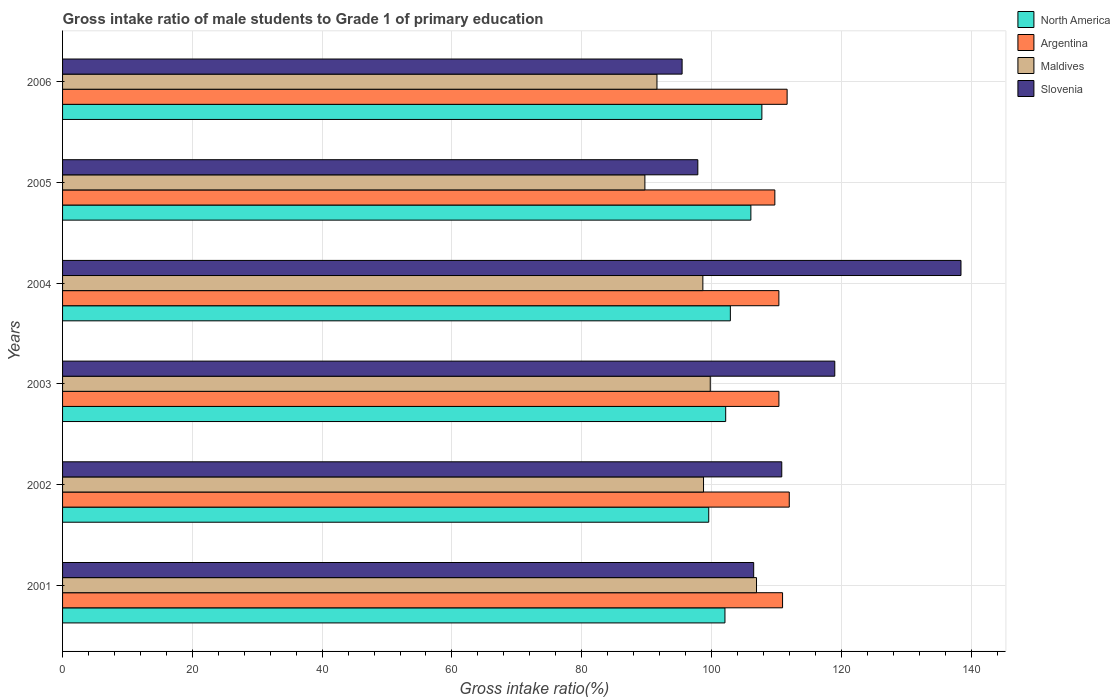How many different coloured bars are there?
Your response must be concise. 4. Are the number of bars per tick equal to the number of legend labels?
Provide a short and direct response. Yes. In how many cases, is the number of bars for a given year not equal to the number of legend labels?
Make the answer very short. 0. What is the gross intake ratio in Maldives in 2001?
Offer a very short reply. 106.93. Across all years, what is the maximum gross intake ratio in Maldives?
Offer a terse response. 106.93. Across all years, what is the minimum gross intake ratio in Argentina?
Your response must be concise. 109.76. In which year was the gross intake ratio in North America minimum?
Your response must be concise. 2002. What is the total gross intake ratio in Argentina in the graph?
Your answer should be very brief. 665.11. What is the difference between the gross intake ratio in North America in 2005 and that in 2006?
Your answer should be very brief. -1.7. What is the difference between the gross intake ratio in Argentina in 2004 and the gross intake ratio in North America in 2005?
Your answer should be very brief. 4.31. What is the average gross intake ratio in Slovenia per year?
Ensure brevity in your answer.  111.35. In the year 2004, what is the difference between the gross intake ratio in Slovenia and gross intake ratio in Argentina?
Your answer should be compact. 28.06. What is the ratio of the gross intake ratio in North America in 2002 to that in 2005?
Make the answer very short. 0.94. What is the difference between the highest and the second highest gross intake ratio in North America?
Keep it short and to the point. 1.7. What is the difference between the highest and the lowest gross intake ratio in Maldives?
Your response must be concise. 17.2. Is it the case that in every year, the sum of the gross intake ratio in Maldives and gross intake ratio in Argentina is greater than the sum of gross intake ratio in North America and gross intake ratio in Slovenia?
Ensure brevity in your answer.  No. What does the 4th bar from the top in 2004 represents?
Keep it short and to the point. North America. What does the 4th bar from the bottom in 2002 represents?
Your response must be concise. Slovenia. Is it the case that in every year, the sum of the gross intake ratio in Argentina and gross intake ratio in Maldives is greater than the gross intake ratio in North America?
Keep it short and to the point. Yes. How many bars are there?
Ensure brevity in your answer.  24. Are all the bars in the graph horizontal?
Provide a short and direct response. Yes. What is the difference between two consecutive major ticks on the X-axis?
Keep it short and to the point. 20. Are the values on the major ticks of X-axis written in scientific E-notation?
Make the answer very short. No. Where does the legend appear in the graph?
Your answer should be compact. Top right. How are the legend labels stacked?
Provide a short and direct response. Vertical. What is the title of the graph?
Offer a very short reply. Gross intake ratio of male students to Grade 1 of primary education. What is the label or title of the X-axis?
Ensure brevity in your answer.  Gross intake ratio(%). What is the label or title of the Y-axis?
Make the answer very short. Years. What is the Gross intake ratio(%) in North America in 2001?
Provide a succinct answer. 102.07. What is the Gross intake ratio(%) in Argentina in 2001?
Provide a succinct answer. 110.95. What is the Gross intake ratio(%) in Maldives in 2001?
Your answer should be very brief. 106.93. What is the Gross intake ratio(%) of Slovenia in 2001?
Make the answer very short. 106.5. What is the Gross intake ratio(%) in North America in 2002?
Ensure brevity in your answer.  99.57. What is the Gross intake ratio(%) in Argentina in 2002?
Give a very brief answer. 111.98. What is the Gross intake ratio(%) of Maldives in 2002?
Ensure brevity in your answer.  98.77. What is the Gross intake ratio(%) in Slovenia in 2002?
Provide a succinct answer. 110.83. What is the Gross intake ratio(%) in North America in 2003?
Your response must be concise. 102.18. What is the Gross intake ratio(%) of Argentina in 2003?
Give a very brief answer. 110.39. What is the Gross intake ratio(%) in Maldives in 2003?
Your response must be concise. 99.81. What is the Gross intake ratio(%) in Slovenia in 2003?
Your answer should be compact. 118.99. What is the Gross intake ratio(%) of North America in 2004?
Keep it short and to the point. 102.9. What is the Gross intake ratio(%) of Argentina in 2004?
Provide a succinct answer. 110.38. What is the Gross intake ratio(%) in Maldives in 2004?
Your answer should be compact. 98.67. What is the Gross intake ratio(%) of Slovenia in 2004?
Your answer should be very brief. 138.44. What is the Gross intake ratio(%) of North America in 2005?
Provide a succinct answer. 106.07. What is the Gross intake ratio(%) in Argentina in 2005?
Offer a very short reply. 109.76. What is the Gross intake ratio(%) in Maldives in 2005?
Offer a very short reply. 89.74. What is the Gross intake ratio(%) in Slovenia in 2005?
Provide a short and direct response. 97.89. What is the Gross intake ratio(%) of North America in 2006?
Provide a succinct answer. 107.76. What is the Gross intake ratio(%) in Argentina in 2006?
Make the answer very short. 111.65. What is the Gross intake ratio(%) in Maldives in 2006?
Provide a short and direct response. 91.59. What is the Gross intake ratio(%) in Slovenia in 2006?
Give a very brief answer. 95.47. Across all years, what is the maximum Gross intake ratio(%) of North America?
Your response must be concise. 107.76. Across all years, what is the maximum Gross intake ratio(%) in Argentina?
Offer a very short reply. 111.98. Across all years, what is the maximum Gross intake ratio(%) of Maldives?
Your answer should be very brief. 106.93. Across all years, what is the maximum Gross intake ratio(%) in Slovenia?
Keep it short and to the point. 138.44. Across all years, what is the minimum Gross intake ratio(%) of North America?
Provide a short and direct response. 99.57. Across all years, what is the minimum Gross intake ratio(%) in Argentina?
Ensure brevity in your answer.  109.76. Across all years, what is the minimum Gross intake ratio(%) of Maldives?
Your answer should be very brief. 89.74. Across all years, what is the minimum Gross intake ratio(%) in Slovenia?
Offer a terse response. 95.47. What is the total Gross intake ratio(%) in North America in the graph?
Your answer should be compact. 620.56. What is the total Gross intake ratio(%) of Argentina in the graph?
Your answer should be very brief. 665.11. What is the total Gross intake ratio(%) in Maldives in the graph?
Give a very brief answer. 585.51. What is the total Gross intake ratio(%) of Slovenia in the graph?
Offer a very short reply. 668.12. What is the difference between the Gross intake ratio(%) in North America in 2001 and that in 2002?
Provide a short and direct response. 2.5. What is the difference between the Gross intake ratio(%) of Argentina in 2001 and that in 2002?
Keep it short and to the point. -1.03. What is the difference between the Gross intake ratio(%) in Maldives in 2001 and that in 2002?
Keep it short and to the point. 8.16. What is the difference between the Gross intake ratio(%) of Slovenia in 2001 and that in 2002?
Provide a succinct answer. -4.33. What is the difference between the Gross intake ratio(%) of North America in 2001 and that in 2003?
Your answer should be very brief. -0.11. What is the difference between the Gross intake ratio(%) of Argentina in 2001 and that in 2003?
Your answer should be very brief. 0.56. What is the difference between the Gross intake ratio(%) of Maldives in 2001 and that in 2003?
Ensure brevity in your answer.  7.13. What is the difference between the Gross intake ratio(%) in Slovenia in 2001 and that in 2003?
Your answer should be compact. -12.49. What is the difference between the Gross intake ratio(%) in North America in 2001 and that in 2004?
Make the answer very short. -0.83. What is the difference between the Gross intake ratio(%) of Argentina in 2001 and that in 2004?
Your answer should be very brief. 0.57. What is the difference between the Gross intake ratio(%) of Maldives in 2001 and that in 2004?
Your response must be concise. 8.27. What is the difference between the Gross intake ratio(%) of Slovenia in 2001 and that in 2004?
Provide a succinct answer. -31.94. What is the difference between the Gross intake ratio(%) of North America in 2001 and that in 2005?
Give a very brief answer. -3.99. What is the difference between the Gross intake ratio(%) of Argentina in 2001 and that in 2005?
Offer a very short reply. 1.19. What is the difference between the Gross intake ratio(%) in Maldives in 2001 and that in 2005?
Provide a succinct answer. 17.2. What is the difference between the Gross intake ratio(%) of Slovenia in 2001 and that in 2005?
Provide a succinct answer. 8.61. What is the difference between the Gross intake ratio(%) in North America in 2001 and that in 2006?
Ensure brevity in your answer.  -5.69. What is the difference between the Gross intake ratio(%) of Argentina in 2001 and that in 2006?
Keep it short and to the point. -0.7. What is the difference between the Gross intake ratio(%) in Maldives in 2001 and that in 2006?
Offer a very short reply. 15.34. What is the difference between the Gross intake ratio(%) in Slovenia in 2001 and that in 2006?
Provide a succinct answer. 11.03. What is the difference between the Gross intake ratio(%) in North America in 2002 and that in 2003?
Give a very brief answer. -2.61. What is the difference between the Gross intake ratio(%) in Argentina in 2002 and that in 2003?
Offer a terse response. 1.6. What is the difference between the Gross intake ratio(%) in Maldives in 2002 and that in 2003?
Keep it short and to the point. -1.03. What is the difference between the Gross intake ratio(%) of Slovenia in 2002 and that in 2003?
Your answer should be very brief. -8.17. What is the difference between the Gross intake ratio(%) of North America in 2002 and that in 2004?
Make the answer very short. -3.33. What is the difference between the Gross intake ratio(%) in Argentina in 2002 and that in 2004?
Offer a very short reply. 1.6. What is the difference between the Gross intake ratio(%) of Maldives in 2002 and that in 2004?
Provide a short and direct response. 0.1. What is the difference between the Gross intake ratio(%) in Slovenia in 2002 and that in 2004?
Give a very brief answer. -27.62. What is the difference between the Gross intake ratio(%) in North America in 2002 and that in 2005?
Your response must be concise. -6.49. What is the difference between the Gross intake ratio(%) in Argentina in 2002 and that in 2005?
Make the answer very short. 2.22. What is the difference between the Gross intake ratio(%) of Maldives in 2002 and that in 2005?
Your answer should be compact. 9.04. What is the difference between the Gross intake ratio(%) in Slovenia in 2002 and that in 2005?
Provide a succinct answer. 12.93. What is the difference between the Gross intake ratio(%) of North America in 2002 and that in 2006?
Offer a very short reply. -8.19. What is the difference between the Gross intake ratio(%) in Argentina in 2002 and that in 2006?
Give a very brief answer. 0.33. What is the difference between the Gross intake ratio(%) of Maldives in 2002 and that in 2006?
Your response must be concise. 7.18. What is the difference between the Gross intake ratio(%) in Slovenia in 2002 and that in 2006?
Offer a terse response. 15.36. What is the difference between the Gross intake ratio(%) of North America in 2003 and that in 2004?
Your answer should be compact. -0.72. What is the difference between the Gross intake ratio(%) in Argentina in 2003 and that in 2004?
Offer a terse response. 0.01. What is the difference between the Gross intake ratio(%) of Maldives in 2003 and that in 2004?
Your answer should be very brief. 1.14. What is the difference between the Gross intake ratio(%) of Slovenia in 2003 and that in 2004?
Give a very brief answer. -19.45. What is the difference between the Gross intake ratio(%) of North America in 2003 and that in 2005?
Offer a terse response. -3.88. What is the difference between the Gross intake ratio(%) of Argentina in 2003 and that in 2005?
Provide a succinct answer. 0.63. What is the difference between the Gross intake ratio(%) of Maldives in 2003 and that in 2005?
Offer a very short reply. 10.07. What is the difference between the Gross intake ratio(%) in Slovenia in 2003 and that in 2005?
Your answer should be very brief. 21.1. What is the difference between the Gross intake ratio(%) of North America in 2003 and that in 2006?
Ensure brevity in your answer.  -5.58. What is the difference between the Gross intake ratio(%) in Argentina in 2003 and that in 2006?
Offer a terse response. -1.27. What is the difference between the Gross intake ratio(%) in Maldives in 2003 and that in 2006?
Offer a very short reply. 8.21. What is the difference between the Gross intake ratio(%) in Slovenia in 2003 and that in 2006?
Your answer should be compact. 23.53. What is the difference between the Gross intake ratio(%) of North America in 2004 and that in 2005?
Give a very brief answer. -3.16. What is the difference between the Gross intake ratio(%) in Argentina in 2004 and that in 2005?
Provide a succinct answer. 0.62. What is the difference between the Gross intake ratio(%) of Maldives in 2004 and that in 2005?
Your answer should be very brief. 8.93. What is the difference between the Gross intake ratio(%) in Slovenia in 2004 and that in 2005?
Provide a short and direct response. 40.55. What is the difference between the Gross intake ratio(%) in North America in 2004 and that in 2006?
Make the answer very short. -4.86. What is the difference between the Gross intake ratio(%) of Argentina in 2004 and that in 2006?
Your answer should be very brief. -1.27. What is the difference between the Gross intake ratio(%) of Maldives in 2004 and that in 2006?
Offer a very short reply. 7.07. What is the difference between the Gross intake ratio(%) of Slovenia in 2004 and that in 2006?
Your answer should be very brief. 42.97. What is the difference between the Gross intake ratio(%) in North America in 2005 and that in 2006?
Offer a terse response. -1.7. What is the difference between the Gross intake ratio(%) of Argentina in 2005 and that in 2006?
Provide a short and direct response. -1.89. What is the difference between the Gross intake ratio(%) of Maldives in 2005 and that in 2006?
Keep it short and to the point. -1.86. What is the difference between the Gross intake ratio(%) in Slovenia in 2005 and that in 2006?
Ensure brevity in your answer.  2.42. What is the difference between the Gross intake ratio(%) in North America in 2001 and the Gross intake ratio(%) in Argentina in 2002?
Provide a short and direct response. -9.91. What is the difference between the Gross intake ratio(%) in North America in 2001 and the Gross intake ratio(%) in Maldives in 2002?
Offer a terse response. 3.3. What is the difference between the Gross intake ratio(%) of North America in 2001 and the Gross intake ratio(%) of Slovenia in 2002?
Keep it short and to the point. -8.75. What is the difference between the Gross intake ratio(%) in Argentina in 2001 and the Gross intake ratio(%) in Maldives in 2002?
Give a very brief answer. 12.18. What is the difference between the Gross intake ratio(%) in Argentina in 2001 and the Gross intake ratio(%) in Slovenia in 2002?
Make the answer very short. 0.12. What is the difference between the Gross intake ratio(%) of Maldives in 2001 and the Gross intake ratio(%) of Slovenia in 2002?
Offer a very short reply. -3.89. What is the difference between the Gross intake ratio(%) of North America in 2001 and the Gross intake ratio(%) of Argentina in 2003?
Offer a terse response. -8.32. What is the difference between the Gross intake ratio(%) of North America in 2001 and the Gross intake ratio(%) of Maldives in 2003?
Your response must be concise. 2.27. What is the difference between the Gross intake ratio(%) in North America in 2001 and the Gross intake ratio(%) in Slovenia in 2003?
Provide a succinct answer. -16.92. What is the difference between the Gross intake ratio(%) in Argentina in 2001 and the Gross intake ratio(%) in Maldives in 2003?
Provide a short and direct response. 11.14. What is the difference between the Gross intake ratio(%) in Argentina in 2001 and the Gross intake ratio(%) in Slovenia in 2003?
Your answer should be compact. -8.05. What is the difference between the Gross intake ratio(%) in Maldives in 2001 and the Gross intake ratio(%) in Slovenia in 2003?
Make the answer very short. -12.06. What is the difference between the Gross intake ratio(%) of North America in 2001 and the Gross intake ratio(%) of Argentina in 2004?
Offer a very short reply. -8.31. What is the difference between the Gross intake ratio(%) of North America in 2001 and the Gross intake ratio(%) of Maldives in 2004?
Your response must be concise. 3.4. What is the difference between the Gross intake ratio(%) of North America in 2001 and the Gross intake ratio(%) of Slovenia in 2004?
Your answer should be very brief. -36.37. What is the difference between the Gross intake ratio(%) in Argentina in 2001 and the Gross intake ratio(%) in Maldives in 2004?
Your answer should be compact. 12.28. What is the difference between the Gross intake ratio(%) in Argentina in 2001 and the Gross intake ratio(%) in Slovenia in 2004?
Give a very brief answer. -27.49. What is the difference between the Gross intake ratio(%) in Maldives in 2001 and the Gross intake ratio(%) in Slovenia in 2004?
Provide a short and direct response. -31.51. What is the difference between the Gross intake ratio(%) of North America in 2001 and the Gross intake ratio(%) of Argentina in 2005?
Your response must be concise. -7.69. What is the difference between the Gross intake ratio(%) in North America in 2001 and the Gross intake ratio(%) in Maldives in 2005?
Offer a very short reply. 12.34. What is the difference between the Gross intake ratio(%) in North America in 2001 and the Gross intake ratio(%) in Slovenia in 2005?
Your response must be concise. 4.18. What is the difference between the Gross intake ratio(%) in Argentina in 2001 and the Gross intake ratio(%) in Maldives in 2005?
Provide a succinct answer. 21.21. What is the difference between the Gross intake ratio(%) of Argentina in 2001 and the Gross intake ratio(%) of Slovenia in 2005?
Your answer should be very brief. 13.06. What is the difference between the Gross intake ratio(%) in Maldives in 2001 and the Gross intake ratio(%) in Slovenia in 2005?
Give a very brief answer. 9.04. What is the difference between the Gross intake ratio(%) in North America in 2001 and the Gross intake ratio(%) in Argentina in 2006?
Offer a very short reply. -9.58. What is the difference between the Gross intake ratio(%) of North America in 2001 and the Gross intake ratio(%) of Maldives in 2006?
Your answer should be compact. 10.48. What is the difference between the Gross intake ratio(%) in North America in 2001 and the Gross intake ratio(%) in Slovenia in 2006?
Your response must be concise. 6.6. What is the difference between the Gross intake ratio(%) in Argentina in 2001 and the Gross intake ratio(%) in Maldives in 2006?
Make the answer very short. 19.35. What is the difference between the Gross intake ratio(%) of Argentina in 2001 and the Gross intake ratio(%) of Slovenia in 2006?
Offer a terse response. 15.48. What is the difference between the Gross intake ratio(%) in Maldives in 2001 and the Gross intake ratio(%) in Slovenia in 2006?
Offer a very short reply. 11.46. What is the difference between the Gross intake ratio(%) in North America in 2002 and the Gross intake ratio(%) in Argentina in 2003?
Your answer should be very brief. -10.82. What is the difference between the Gross intake ratio(%) in North America in 2002 and the Gross intake ratio(%) in Maldives in 2003?
Ensure brevity in your answer.  -0.23. What is the difference between the Gross intake ratio(%) of North America in 2002 and the Gross intake ratio(%) of Slovenia in 2003?
Your response must be concise. -19.42. What is the difference between the Gross intake ratio(%) of Argentina in 2002 and the Gross intake ratio(%) of Maldives in 2003?
Your answer should be compact. 12.18. What is the difference between the Gross intake ratio(%) in Argentina in 2002 and the Gross intake ratio(%) in Slovenia in 2003?
Ensure brevity in your answer.  -7.01. What is the difference between the Gross intake ratio(%) of Maldives in 2002 and the Gross intake ratio(%) of Slovenia in 2003?
Provide a succinct answer. -20.22. What is the difference between the Gross intake ratio(%) of North America in 2002 and the Gross intake ratio(%) of Argentina in 2004?
Your response must be concise. -10.81. What is the difference between the Gross intake ratio(%) in North America in 2002 and the Gross intake ratio(%) in Maldives in 2004?
Make the answer very short. 0.9. What is the difference between the Gross intake ratio(%) in North America in 2002 and the Gross intake ratio(%) in Slovenia in 2004?
Make the answer very short. -38.87. What is the difference between the Gross intake ratio(%) in Argentina in 2002 and the Gross intake ratio(%) in Maldives in 2004?
Your answer should be very brief. 13.32. What is the difference between the Gross intake ratio(%) in Argentina in 2002 and the Gross intake ratio(%) in Slovenia in 2004?
Offer a very short reply. -26.46. What is the difference between the Gross intake ratio(%) of Maldives in 2002 and the Gross intake ratio(%) of Slovenia in 2004?
Offer a very short reply. -39.67. What is the difference between the Gross intake ratio(%) in North America in 2002 and the Gross intake ratio(%) in Argentina in 2005?
Make the answer very short. -10.19. What is the difference between the Gross intake ratio(%) in North America in 2002 and the Gross intake ratio(%) in Maldives in 2005?
Provide a succinct answer. 9.84. What is the difference between the Gross intake ratio(%) in North America in 2002 and the Gross intake ratio(%) in Slovenia in 2005?
Give a very brief answer. 1.68. What is the difference between the Gross intake ratio(%) in Argentina in 2002 and the Gross intake ratio(%) in Maldives in 2005?
Offer a very short reply. 22.25. What is the difference between the Gross intake ratio(%) in Argentina in 2002 and the Gross intake ratio(%) in Slovenia in 2005?
Keep it short and to the point. 14.09. What is the difference between the Gross intake ratio(%) in Maldives in 2002 and the Gross intake ratio(%) in Slovenia in 2005?
Make the answer very short. 0.88. What is the difference between the Gross intake ratio(%) of North America in 2002 and the Gross intake ratio(%) of Argentina in 2006?
Your response must be concise. -12.08. What is the difference between the Gross intake ratio(%) of North America in 2002 and the Gross intake ratio(%) of Maldives in 2006?
Provide a succinct answer. 7.98. What is the difference between the Gross intake ratio(%) in North America in 2002 and the Gross intake ratio(%) in Slovenia in 2006?
Ensure brevity in your answer.  4.1. What is the difference between the Gross intake ratio(%) of Argentina in 2002 and the Gross intake ratio(%) of Maldives in 2006?
Make the answer very short. 20.39. What is the difference between the Gross intake ratio(%) in Argentina in 2002 and the Gross intake ratio(%) in Slovenia in 2006?
Give a very brief answer. 16.51. What is the difference between the Gross intake ratio(%) in Maldives in 2002 and the Gross intake ratio(%) in Slovenia in 2006?
Give a very brief answer. 3.3. What is the difference between the Gross intake ratio(%) of North America in 2003 and the Gross intake ratio(%) of Argentina in 2004?
Give a very brief answer. -8.2. What is the difference between the Gross intake ratio(%) in North America in 2003 and the Gross intake ratio(%) in Maldives in 2004?
Your answer should be very brief. 3.52. What is the difference between the Gross intake ratio(%) of North America in 2003 and the Gross intake ratio(%) of Slovenia in 2004?
Your response must be concise. -36.26. What is the difference between the Gross intake ratio(%) in Argentina in 2003 and the Gross intake ratio(%) in Maldives in 2004?
Keep it short and to the point. 11.72. What is the difference between the Gross intake ratio(%) of Argentina in 2003 and the Gross intake ratio(%) of Slovenia in 2004?
Make the answer very short. -28.06. What is the difference between the Gross intake ratio(%) of Maldives in 2003 and the Gross intake ratio(%) of Slovenia in 2004?
Provide a short and direct response. -38.64. What is the difference between the Gross intake ratio(%) in North America in 2003 and the Gross intake ratio(%) in Argentina in 2005?
Your response must be concise. -7.58. What is the difference between the Gross intake ratio(%) in North America in 2003 and the Gross intake ratio(%) in Maldives in 2005?
Ensure brevity in your answer.  12.45. What is the difference between the Gross intake ratio(%) in North America in 2003 and the Gross intake ratio(%) in Slovenia in 2005?
Give a very brief answer. 4.29. What is the difference between the Gross intake ratio(%) of Argentina in 2003 and the Gross intake ratio(%) of Maldives in 2005?
Your answer should be compact. 20.65. What is the difference between the Gross intake ratio(%) in Argentina in 2003 and the Gross intake ratio(%) in Slovenia in 2005?
Your response must be concise. 12.5. What is the difference between the Gross intake ratio(%) of Maldives in 2003 and the Gross intake ratio(%) of Slovenia in 2005?
Provide a short and direct response. 1.91. What is the difference between the Gross intake ratio(%) of North America in 2003 and the Gross intake ratio(%) of Argentina in 2006?
Provide a short and direct response. -9.47. What is the difference between the Gross intake ratio(%) in North America in 2003 and the Gross intake ratio(%) in Maldives in 2006?
Your answer should be very brief. 10.59. What is the difference between the Gross intake ratio(%) of North America in 2003 and the Gross intake ratio(%) of Slovenia in 2006?
Your response must be concise. 6.71. What is the difference between the Gross intake ratio(%) in Argentina in 2003 and the Gross intake ratio(%) in Maldives in 2006?
Make the answer very short. 18.79. What is the difference between the Gross intake ratio(%) in Argentina in 2003 and the Gross intake ratio(%) in Slovenia in 2006?
Ensure brevity in your answer.  14.92. What is the difference between the Gross intake ratio(%) of Maldives in 2003 and the Gross intake ratio(%) of Slovenia in 2006?
Make the answer very short. 4.34. What is the difference between the Gross intake ratio(%) in North America in 2004 and the Gross intake ratio(%) in Argentina in 2005?
Offer a terse response. -6.86. What is the difference between the Gross intake ratio(%) of North America in 2004 and the Gross intake ratio(%) of Maldives in 2005?
Your answer should be compact. 13.17. What is the difference between the Gross intake ratio(%) of North America in 2004 and the Gross intake ratio(%) of Slovenia in 2005?
Keep it short and to the point. 5.01. What is the difference between the Gross intake ratio(%) of Argentina in 2004 and the Gross intake ratio(%) of Maldives in 2005?
Keep it short and to the point. 20.64. What is the difference between the Gross intake ratio(%) in Argentina in 2004 and the Gross intake ratio(%) in Slovenia in 2005?
Your response must be concise. 12.49. What is the difference between the Gross intake ratio(%) in Maldives in 2004 and the Gross intake ratio(%) in Slovenia in 2005?
Provide a short and direct response. 0.78. What is the difference between the Gross intake ratio(%) in North America in 2004 and the Gross intake ratio(%) in Argentina in 2006?
Offer a terse response. -8.75. What is the difference between the Gross intake ratio(%) of North America in 2004 and the Gross intake ratio(%) of Maldives in 2006?
Offer a terse response. 11.31. What is the difference between the Gross intake ratio(%) in North America in 2004 and the Gross intake ratio(%) in Slovenia in 2006?
Offer a terse response. 7.43. What is the difference between the Gross intake ratio(%) of Argentina in 2004 and the Gross intake ratio(%) of Maldives in 2006?
Your response must be concise. 18.79. What is the difference between the Gross intake ratio(%) in Argentina in 2004 and the Gross intake ratio(%) in Slovenia in 2006?
Offer a very short reply. 14.91. What is the difference between the Gross intake ratio(%) of Maldives in 2004 and the Gross intake ratio(%) of Slovenia in 2006?
Offer a terse response. 3.2. What is the difference between the Gross intake ratio(%) of North America in 2005 and the Gross intake ratio(%) of Argentina in 2006?
Your answer should be very brief. -5.59. What is the difference between the Gross intake ratio(%) of North America in 2005 and the Gross intake ratio(%) of Maldives in 2006?
Offer a very short reply. 14.47. What is the difference between the Gross intake ratio(%) of North America in 2005 and the Gross intake ratio(%) of Slovenia in 2006?
Make the answer very short. 10.6. What is the difference between the Gross intake ratio(%) in Argentina in 2005 and the Gross intake ratio(%) in Maldives in 2006?
Give a very brief answer. 18.17. What is the difference between the Gross intake ratio(%) in Argentina in 2005 and the Gross intake ratio(%) in Slovenia in 2006?
Your response must be concise. 14.29. What is the difference between the Gross intake ratio(%) in Maldives in 2005 and the Gross intake ratio(%) in Slovenia in 2006?
Ensure brevity in your answer.  -5.73. What is the average Gross intake ratio(%) in North America per year?
Ensure brevity in your answer.  103.43. What is the average Gross intake ratio(%) of Argentina per year?
Your answer should be compact. 110.85. What is the average Gross intake ratio(%) of Maldives per year?
Your response must be concise. 97.58. What is the average Gross intake ratio(%) in Slovenia per year?
Keep it short and to the point. 111.35. In the year 2001, what is the difference between the Gross intake ratio(%) of North America and Gross intake ratio(%) of Argentina?
Offer a very short reply. -8.88. In the year 2001, what is the difference between the Gross intake ratio(%) of North America and Gross intake ratio(%) of Maldives?
Provide a short and direct response. -4.86. In the year 2001, what is the difference between the Gross intake ratio(%) of North America and Gross intake ratio(%) of Slovenia?
Provide a succinct answer. -4.43. In the year 2001, what is the difference between the Gross intake ratio(%) in Argentina and Gross intake ratio(%) in Maldives?
Keep it short and to the point. 4.01. In the year 2001, what is the difference between the Gross intake ratio(%) of Argentina and Gross intake ratio(%) of Slovenia?
Your answer should be very brief. 4.45. In the year 2001, what is the difference between the Gross intake ratio(%) in Maldives and Gross intake ratio(%) in Slovenia?
Ensure brevity in your answer.  0.43. In the year 2002, what is the difference between the Gross intake ratio(%) of North America and Gross intake ratio(%) of Argentina?
Offer a very short reply. -12.41. In the year 2002, what is the difference between the Gross intake ratio(%) in North America and Gross intake ratio(%) in Maldives?
Your answer should be very brief. 0.8. In the year 2002, what is the difference between the Gross intake ratio(%) in North America and Gross intake ratio(%) in Slovenia?
Make the answer very short. -11.25. In the year 2002, what is the difference between the Gross intake ratio(%) of Argentina and Gross intake ratio(%) of Maldives?
Ensure brevity in your answer.  13.21. In the year 2002, what is the difference between the Gross intake ratio(%) in Argentina and Gross intake ratio(%) in Slovenia?
Offer a terse response. 1.16. In the year 2002, what is the difference between the Gross intake ratio(%) of Maldives and Gross intake ratio(%) of Slovenia?
Give a very brief answer. -12.05. In the year 2003, what is the difference between the Gross intake ratio(%) of North America and Gross intake ratio(%) of Argentina?
Keep it short and to the point. -8.2. In the year 2003, what is the difference between the Gross intake ratio(%) of North America and Gross intake ratio(%) of Maldives?
Give a very brief answer. 2.38. In the year 2003, what is the difference between the Gross intake ratio(%) in North America and Gross intake ratio(%) in Slovenia?
Provide a short and direct response. -16.81. In the year 2003, what is the difference between the Gross intake ratio(%) of Argentina and Gross intake ratio(%) of Maldives?
Provide a succinct answer. 10.58. In the year 2003, what is the difference between the Gross intake ratio(%) in Argentina and Gross intake ratio(%) in Slovenia?
Give a very brief answer. -8.61. In the year 2003, what is the difference between the Gross intake ratio(%) in Maldives and Gross intake ratio(%) in Slovenia?
Make the answer very short. -19.19. In the year 2004, what is the difference between the Gross intake ratio(%) of North America and Gross intake ratio(%) of Argentina?
Provide a short and direct response. -7.48. In the year 2004, what is the difference between the Gross intake ratio(%) of North America and Gross intake ratio(%) of Maldives?
Offer a terse response. 4.24. In the year 2004, what is the difference between the Gross intake ratio(%) of North America and Gross intake ratio(%) of Slovenia?
Provide a short and direct response. -35.54. In the year 2004, what is the difference between the Gross intake ratio(%) of Argentina and Gross intake ratio(%) of Maldives?
Provide a succinct answer. 11.71. In the year 2004, what is the difference between the Gross intake ratio(%) in Argentina and Gross intake ratio(%) in Slovenia?
Offer a terse response. -28.06. In the year 2004, what is the difference between the Gross intake ratio(%) of Maldives and Gross intake ratio(%) of Slovenia?
Keep it short and to the point. -39.77. In the year 2005, what is the difference between the Gross intake ratio(%) of North America and Gross intake ratio(%) of Argentina?
Provide a short and direct response. -3.7. In the year 2005, what is the difference between the Gross intake ratio(%) of North America and Gross intake ratio(%) of Maldives?
Provide a short and direct response. 16.33. In the year 2005, what is the difference between the Gross intake ratio(%) of North America and Gross intake ratio(%) of Slovenia?
Provide a succinct answer. 8.17. In the year 2005, what is the difference between the Gross intake ratio(%) in Argentina and Gross intake ratio(%) in Maldives?
Ensure brevity in your answer.  20.03. In the year 2005, what is the difference between the Gross intake ratio(%) of Argentina and Gross intake ratio(%) of Slovenia?
Ensure brevity in your answer.  11.87. In the year 2005, what is the difference between the Gross intake ratio(%) of Maldives and Gross intake ratio(%) of Slovenia?
Offer a terse response. -8.16. In the year 2006, what is the difference between the Gross intake ratio(%) in North America and Gross intake ratio(%) in Argentina?
Give a very brief answer. -3.89. In the year 2006, what is the difference between the Gross intake ratio(%) of North America and Gross intake ratio(%) of Maldives?
Ensure brevity in your answer.  16.17. In the year 2006, what is the difference between the Gross intake ratio(%) in North America and Gross intake ratio(%) in Slovenia?
Provide a succinct answer. 12.29. In the year 2006, what is the difference between the Gross intake ratio(%) in Argentina and Gross intake ratio(%) in Maldives?
Offer a very short reply. 20.06. In the year 2006, what is the difference between the Gross intake ratio(%) of Argentina and Gross intake ratio(%) of Slovenia?
Provide a succinct answer. 16.18. In the year 2006, what is the difference between the Gross intake ratio(%) in Maldives and Gross intake ratio(%) in Slovenia?
Provide a succinct answer. -3.88. What is the ratio of the Gross intake ratio(%) in North America in 2001 to that in 2002?
Your answer should be compact. 1.03. What is the ratio of the Gross intake ratio(%) in Argentina in 2001 to that in 2002?
Offer a very short reply. 0.99. What is the ratio of the Gross intake ratio(%) of Maldives in 2001 to that in 2002?
Give a very brief answer. 1.08. What is the ratio of the Gross intake ratio(%) in Slovenia in 2001 to that in 2002?
Offer a terse response. 0.96. What is the ratio of the Gross intake ratio(%) in North America in 2001 to that in 2003?
Your answer should be very brief. 1. What is the ratio of the Gross intake ratio(%) of Argentina in 2001 to that in 2003?
Keep it short and to the point. 1.01. What is the ratio of the Gross intake ratio(%) in Maldives in 2001 to that in 2003?
Provide a short and direct response. 1.07. What is the ratio of the Gross intake ratio(%) in Slovenia in 2001 to that in 2003?
Ensure brevity in your answer.  0.9. What is the ratio of the Gross intake ratio(%) in North America in 2001 to that in 2004?
Provide a short and direct response. 0.99. What is the ratio of the Gross intake ratio(%) of Maldives in 2001 to that in 2004?
Your answer should be very brief. 1.08. What is the ratio of the Gross intake ratio(%) of Slovenia in 2001 to that in 2004?
Ensure brevity in your answer.  0.77. What is the ratio of the Gross intake ratio(%) of North America in 2001 to that in 2005?
Provide a succinct answer. 0.96. What is the ratio of the Gross intake ratio(%) of Argentina in 2001 to that in 2005?
Make the answer very short. 1.01. What is the ratio of the Gross intake ratio(%) in Maldives in 2001 to that in 2005?
Provide a succinct answer. 1.19. What is the ratio of the Gross intake ratio(%) in Slovenia in 2001 to that in 2005?
Provide a short and direct response. 1.09. What is the ratio of the Gross intake ratio(%) in North America in 2001 to that in 2006?
Offer a very short reply. 0.95. What is the ratio of the Gross intake ratio(%) in Argentina in 2001 to that in 2006?
Give a very brief answer. 0.99. What is the ratio of the Gross intake ratio(%) of Maldives in 2001 to that in 2006?
Keep it short and to the point. 1.17. What is the ratio of the Gross intake ratio(%) in Slovenia in 2001 to that in 2006?
Ensure brevity in your answer.  1.12. What is the ratio of the Gross intake ratio(%) of North America in 2002 to that in 2003?
Offer a very short reply. 0.97. What is the ratio of the Gross intake ratio(%) in Argentina in 2002 to that in 2003?
Make the answer very short. 1.01. What is the ratio of the Gross intake ratio(%) in Slovenia in 2002 to that in 2003?
Give a very brief answer. 0.93. What is the ratio of the Gross intake ratio(%) of North America in 2002 to that in 2004?
Keep it short and to the point. 0.97. What is the ratio of the Gross intake ratio(%) of Argentina in 2002 to that in 2004?
Offer a terse response. 1.01. What is the ratio of the Gross intake ratio(%) in Slovenia in 2002 to that in 2004?
Offer a terse response. 0.8. What is the ratio of the Gross intake ratio(%) of North America in 2002 to that in 2005?
Your response must be concise. 0.94. What is the ratio of the Gross intake ratio(%) in Argentina in 2002 to that in 2005?
Ensure brevity in your answer.  1.02. What is the ratio of the Gross intake ratio(%) of Maldives in 2002 to that in 2005?
Provide a succinct answer. 1.1. What is the ratio of the Gross intake ratio(%) of Slovenia in 2002 to that in 2005?
Give a very brief answer. 1.13. What is the ratio of the Gross intake ratio(%) in North America in 2002 to that in 2006?
Make the answer very short. 0.92. What is the ratio of the Gross intake ratio(%) of Maldives in 2002 to that in 2006?
Make the answer very short. 1.08. What is the ratio of the Gross intake ratio(%) in Slovenia in 2002 to that in 2006?
Your response must be concise. 1.16. What is the ratio of the Gross intake ratio(%) of Maldives in 2003 to that in 2004?
Provide a succinct answer. 1.01. What is the ratio of the Gross intake ratio(%) of Slovenia in 2003 to that in 2004?
Make the answer very short. 0.86. What is the ratio of the Gross intake ratio(%) in North America in 2003 to that in 2005?
Your answer should be compact. 0.96. What is the ratio of the Gross intake ratio(%) of Maldives in 2003 to that in 2005?
Offer a very short reply. 1.11. What is the ratio of the Gross intake ratio(%) of Slovenia in 2003 to that in 2005?
Ensure brevity in your answer.  1.22. What is the ratio of the Gross intake ratio(%) in North America in 2003 to that in 2006?
Make the answer very short. 0.95. What is the ratio of the Gross intake ratio(%) in Argentina in 2003 to that in 2006?
Keep it short and to the point. 0.99. What is the ratio of the Gross intake ratio(%) in Maldives in 2003 to that in 2006?
Your answer should be very brief. 1.09. What is the ratio of the Gross intake ratio(%) of Slovenia in 2003 to that in 2006?
Your response must be concise. 1.25. What is the ratio of the Gross intake ratio(%) of North America in 2004 to that in 2005?
Keep it short and to the point. 0.97. What is the ratio of the Gross intake ratio(%) of Argentina in 2004 to that in 2005?
Your answer should be very brief. 1.01. What is the ratio of the Gross intake ratio(%) in Maldives in 2004 to that in 2005?
Your answer should be compact. 1.1. What is the ratio of the Gross intake ratio(%) in Slovenia in 2004 to that in 2005?
Ensure brevity in your answer.  1.41. What is the ratio of the Gross intake ratio(%) of North America in 2004 to that in 2006?
Offer a very short reply. 0.95. What is the ratio of the Gross intake ratio(%) in Maldives in 2004 to that in 2006?
Your answer should be compact. 1.08. What is the ratio of the Gross intake ratio(%) of Slovenia in 2004 to that in 2006?
Your answer should be very brief. 1.45. What is the ratio of the Gross intake ratio(%) of North America in 2005 to that in 2006?
Your response must be concise. 0.98. What is the ratio of the Gross intake ratio(%) in Argentina in 2005 to that in 2006?
Your answer should be compact. 0.98. What is the ratio of the Gross intake ratio(%) of Maldives in 2005 to that in 2006?
Give a very brief answer. 0.98. What is the ratio of the Gross intake ratio(%) of Slovenia in 2005 to that in 2006?
Make the answer very short. 1.03. What is the difference between the highest and the second highest Gross intake ratio(%) in North America?
Give a very brief answer. 1.7. What is the difference between the highest and the second highest Gross intake ratio(%) in Argentina?
Keep it short and to the point. 0.33. What is the difference between the highest and the second highest Gross intake ratio(%) in Maldives?
Offer a terse response. 7.13. What is the difference between the highest and the second highest Gross intake ratio(%) in Slovenia?
Your answer should be compact. 19.45. What is the difference between the highest and the lowest Gross intake ratio(%) of North America?
Your answer should be very brief. 8.19. What is the difference between the highest and the lowest Gross intake ratio(%) in Argentina?
Ensure brevity in your answer.  2.22. What is the difference between the highest and the lowest Gross intake ratio(%) of Maldives?
Provide a succinct answer. 17.2. What is the difference between the highest and the lowest Gross intake ratio(%) in Slovenia?
Your answer should be compact. 42.97. 